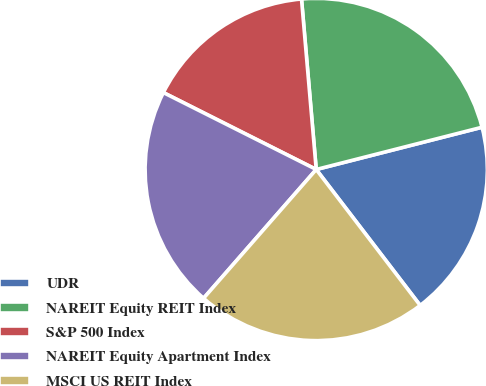Convert chart to OTSL. <chart><loc_0><loc_0><loc_500><loc_500><pie_chart><fcel>UDR<fcel>NAREIT Equity REIT Index<fcel>S&P 500 Index<fcel>NAREIT Equity Apartment Index<fcel>MSCI US REIT Index<nl><fcel>18.58%<fcel>22.4%<fcel>16.21%<fcel>20.98%<fcel>21.83%<nl></chart> 